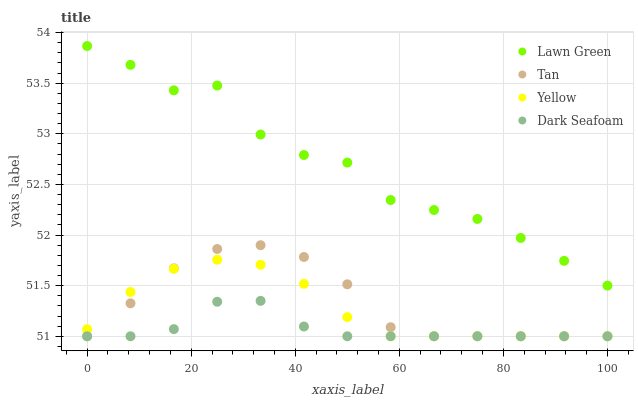Does Dark Seafoam have the minimum area under the curve?
Answer yes or no. Yes. Does Lawn Green have the maximum area under the curve?
Answer yes or no. Yes. Does Tan have the minimum area under the curve?
Answer yes or no. No. Does Tan have the maximum area under the curve?
Answer yes or no. No. Is Yellow the smoothest?
Answer yes or no. Yes. Is Lawn Green the roughest?
Answer yes or no. Yes. Is Tan the smoothest?
Answer yes or no. No. Is Tan the roughest?
Answer yes or no. No. Does Tan have the lowest value?
Answer yes or no. Yes. Does Lawn Green have the highest value?
Answer yes or no. Yes. Does Tan have the highest value?
Answer yes or no. No. Is Yellow less than Lawn Green?
Answer yes or no. Yes. Is Lawn Green greater than Dark Seafoam?
Answer yes or no. Yes. Does Dark Seafoam intersect Tan?
Answer yes or no. Yes. Is Dark Seafoam less than Tan?
Answer yes or no. No. Is Dark Seafoam greater than Tan?
Answer yes or no. No. Does Yellow intersect Lawn Green?
Answer yes or no. No. 